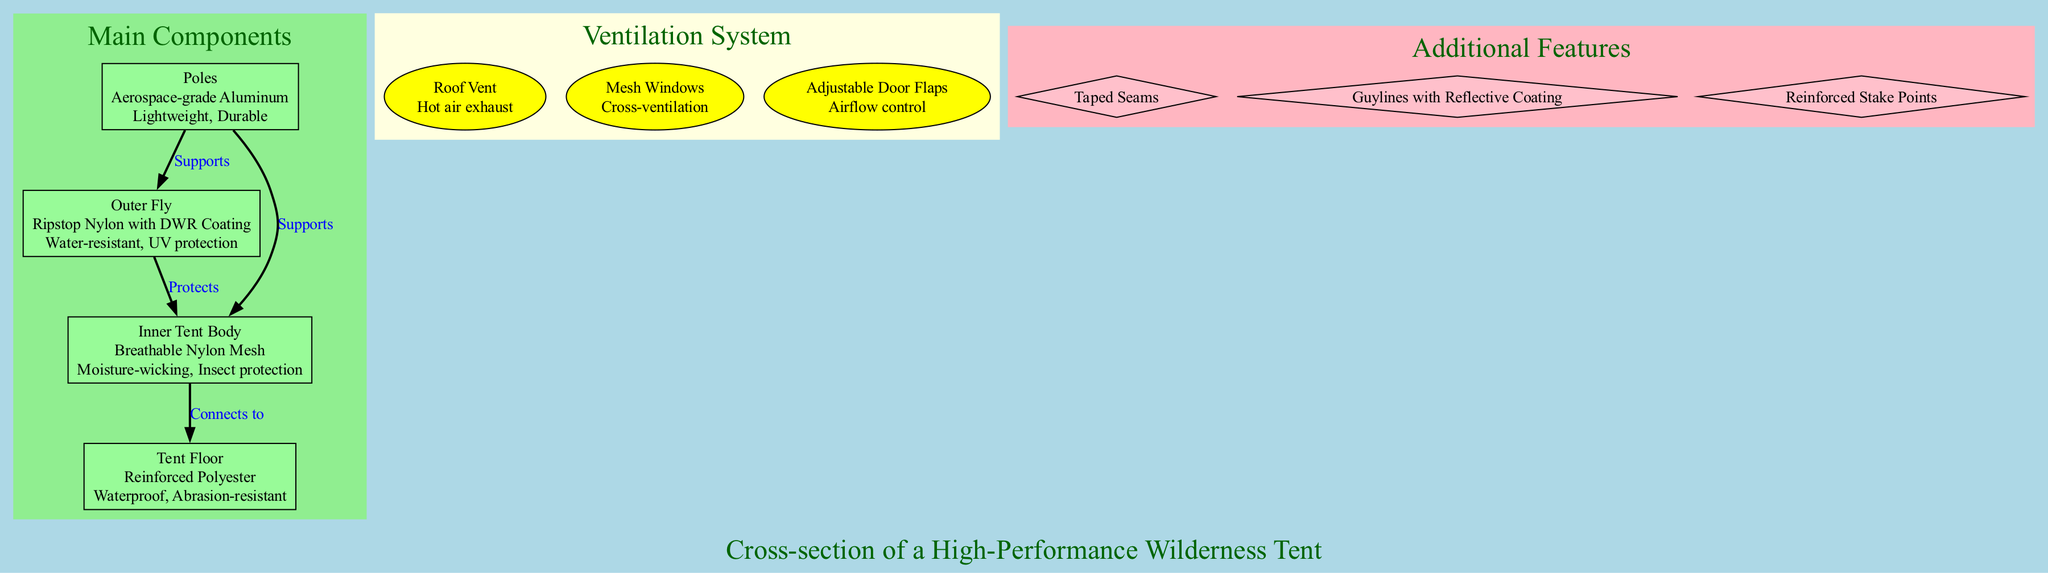What is the material of the Outer Fly? The diagram specifies that the Outer Fly is made from "Ripstop Nylon with DWR Coating." This information is directly available in the node corresponding to the Outer Fly.
Answer: Ripstop Nylon with DWR Coating How many main components are there in the diagram? By counting the nodes listed under the "Main Components" section of the diagram, we can see there are four nodes corresponding to the four main components: Outer Fly, Inner Tent Body, Tent Floor, and Poles.
Answer: 4 What is the function of the Roof Vent? The Roof Vent's function, described in the ventilation system section, indicates it serves as a "Hot air exhaust." This information is explicitly stated in the Roof Vent node.
Answer: Hot air exhaust Which component connects the Inner Tent Body to the Tent Floor? The diagram indicates a direct connection from the Inner Tent Body to the Tent Floor with an edge labeled "Connects to." This relationship is shown by the directional arrow between these two nodes.
Answer: Tent Floor What feature provides insect protection? Looking at the description of the Inner Tent Body, it clearly states that one of its features is "Insect protection," which is explicitly noted in the corresponding node.
Answer: Insect protection How many ventilation system components are listed? The diagram presents three components within the "Ventilation System" section, which can be counted by examining the three nodes: Roof Vent, Mesh Windows, and Adjustable Door Flaps.
Answer: 3 What is the material of the Poles? The diagram specifies that the Poles are made from "Aerospace-grade Aluminum." This information is readily available in the Poles node description.
Answer: Aerospace-grade Aluminum Which additional feature is mentioned in the diagram? Reviewing the "Additional Features" section, multiple features are listed. One concrete example is "Taped Seams," which is explicitly shown as an additional feature in the respective nodes.
Answer: Taped Seams What does the Adjustable Door Flaps control? The function of the Adjustable Door Flaps, as indicated in the corresponding node in the ventilation system, is for "Airflow control." This is clearly stated following its title in that node.
Answer: Airflow control 